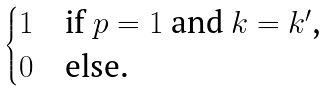<formula> <loc_0><loc_0><loc_500><loc_500>\begin{cases} 1 & \text {if $p=1$ and $k=k^{\prime}$,} \\ 0 & \text {else.} \end{cases}</formula> 